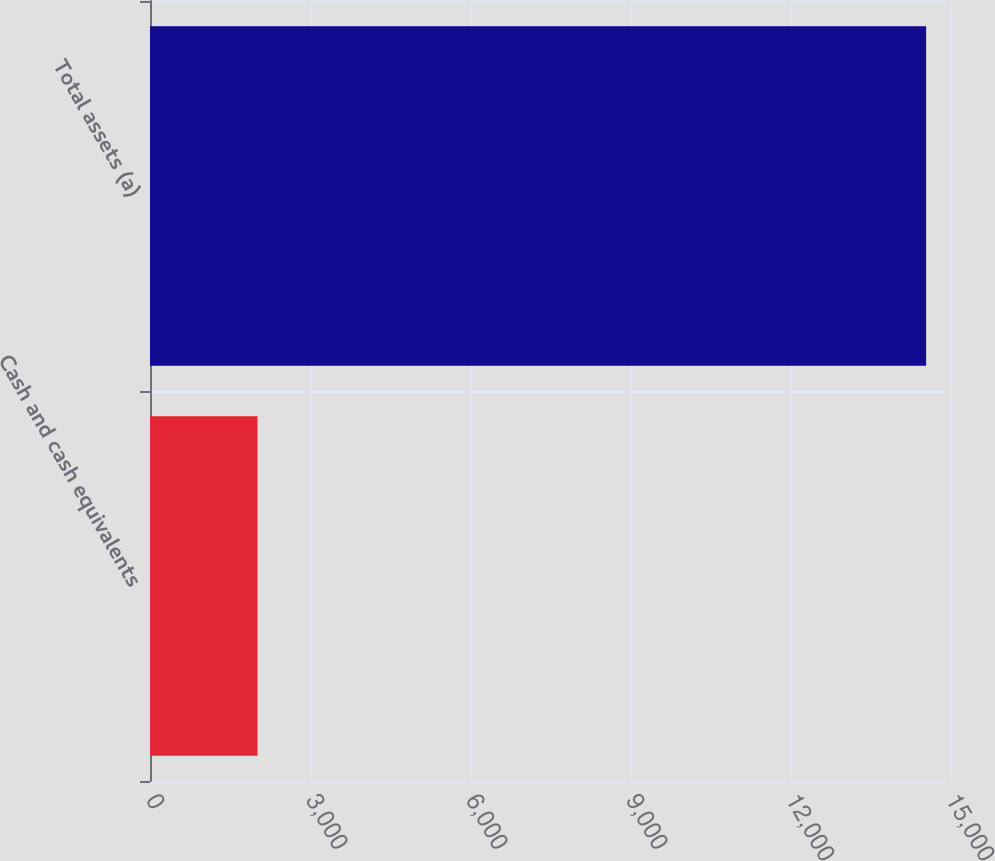Convert chart. <chart><loc_0><loc_0><loc_500><loc_500><bar_chart><fcel>Cash and cash equivalents<fcel>Total assets (a)<nl><fcel>2016<fcel>14552<nl></chart> 